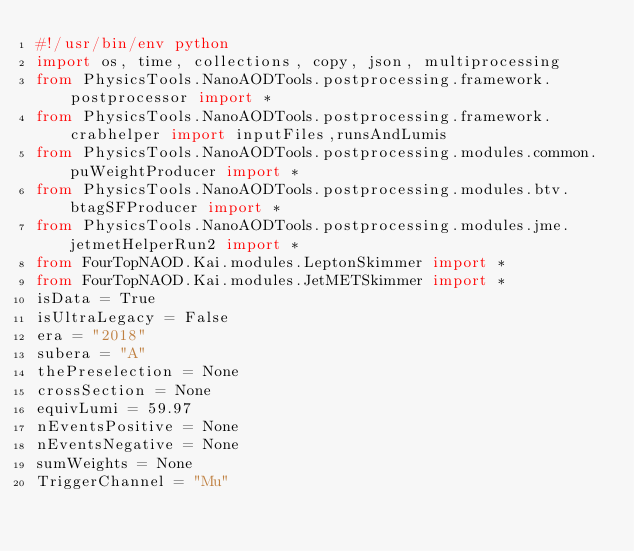<code> <loc_0><loc_0><loc_500><loc_500><_Python_>#!/usr/bin/env python
import os, time, collections, copy, json, multiprocessing
from PhysicsTools.NanoAODTools.postprocessing.framework.postprocessor import * 
from PhysicsTools.NanoAODTools.postprocessing.framework.crabhelper import inputFiles,runsAndLumis
from PhysicsTools.NanoAODTools.postprocessing.modules.common.puWeightProducer import *
from PhysicsTools.NanoAODTools.postprocessing.modules.btv.btagSFProducer import *
from PhysicsTools.NanoAODTools.postprocessing.modules.jme.jetmetHelperRun2 import *
from FourTopNAOD.Kai.modules.LeptonSkimmer import *
from FourTopNAOD.Kai.modules.JetMETSkimmer import *
isData = True
isUltraLegacy = False
era = "2018"
subera = "A"
thePreselection = None
crossSection = None
equivLumi = 59.97
nEventsPositive = None
nEventsNegative = None
sumWeights = None
TriggerChannel = "Mu"</code> 